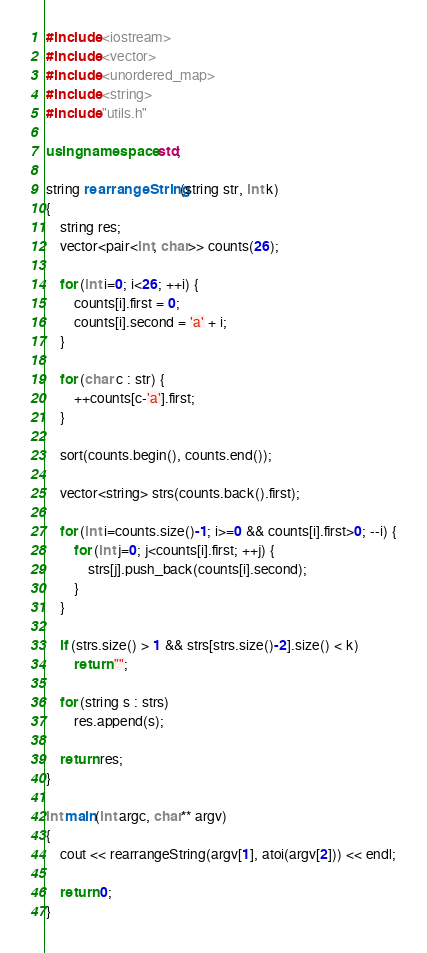Convert code to text. <code><loc_0><loc_0><loc_500><loc_500><_C++_>#include <iostream>
#include <vector>
#include <unordered_map>
#include <string>
#include "utils.h"

using namespace std;

string rearrangeString(string str, int k)
{
    string res;
    vector<pair<int, char>> counts(26);

    for (int i=0; i<26; ++i) {
        counts[i].first = 0;
        counts[i].second = 'a' + i;
    }

    for (char c : str) {
        ++counts[c-'a'].first;
    }

    sort(counts.begin(), counts.end());

    vector<string> strs(counts.back().first);

    for (int i=counts.size()-1; i>=0 && counts[i].first>0; --i) {
        for (int j=0; j<counts[i].first; ++j) {
            strs[j].push_back(counts[i].second);
        }
    }

    if (strs.size() > 1 && strs[strs.size()-2].size() < k)
        return "";

    for (string s : strs)
        res.append(s);

    return res;
}

int main(int argc, char** argv)
{
    cout << rearrangeString(argv[1], atoi(argv[2])) << endl;

    return 0;
}
</code> 